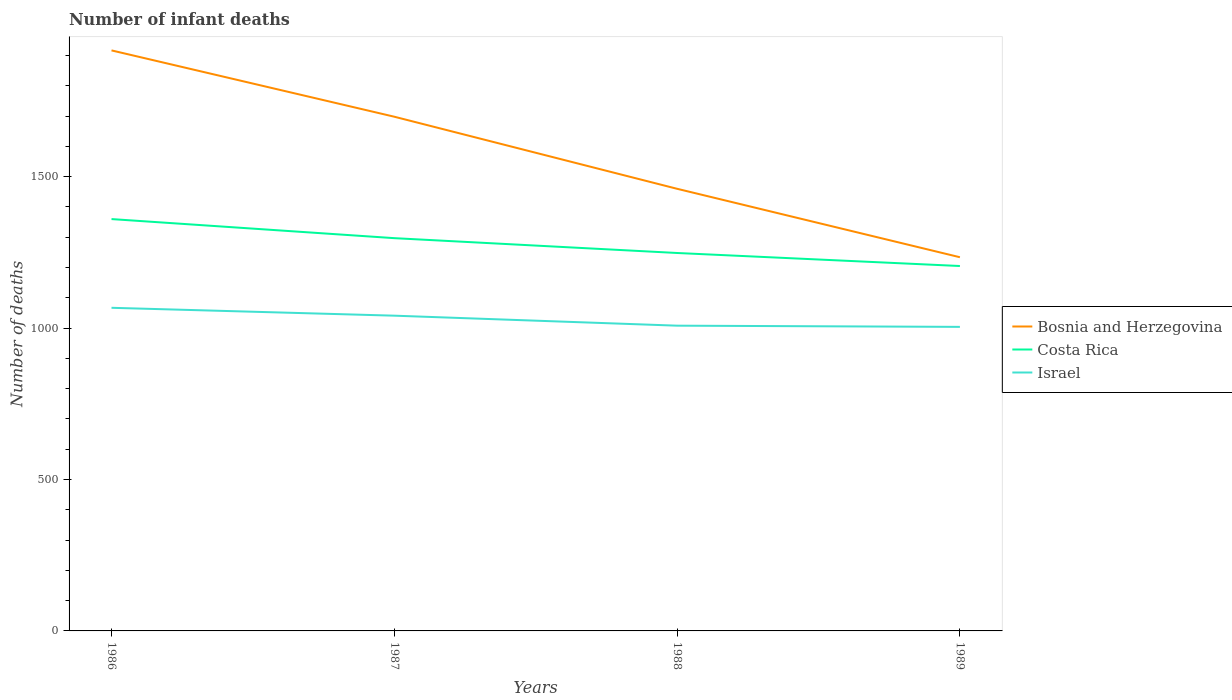Across all years, what is the maximum number of infant deaths in Israel?
Make the answer very short. 1004. In which year was the number of infant deaths in Costa Rica maximum?
Offer a very short reply. 1989. What is the total number of infant deaths in Israel in the graph?
Your answer should be compact. 37. What is the difference between the highest and the second highest number of infant deaths in Costa Rica?
Offer a terse response. 155. Is the number of infant deaths in Costa Rica strictly greater than the number of infant deaths in Bosnia and Herzegovina over the years?
Provide a succinct answer. Yes. What is the difference between two consecutive major ticks on the Y-axis?
Ensure brevity in your answer.  500. Are the values on the major ticks of Y-axis written in scientific E-notation?
Make the answer very short. No. Does the graph contain any zero values?
Offer a terse response. No. Does the graph contain grids?
Provide a succinct answer. No. What is the title of the graph?
Offer a very short reply. Number of infant deaths. Does "Costa Rica" appear as one of the legend labels in the graph?
Ensure brevity in your answer.  Yes. What is the label or title of the X-axis?
Your response must be concise. Years. What is the label or title of the Y-axis?
Provide a succinct answer. Number of deaths. What is the Number of deaths of Bosnia and Herzegovina in 1986?
Your answer should be compact. 1917. What is the Number of deaths in Costa Rica in 1986?
Your response must be concise. 1360. What is the Number of deaths of Israel in 1986?
Provide a succinct answer. 1067. What is the Number of deaths of Bosnia and Herzegovina in 1987?
Provide a short and direct response. 1698. What is the Number of deaths in Costa Rica in 1987?
Offer a terse response. 1297. What is the Number of deaths in Israel in 1987?
Your answer should be compact. 1041. What is the Number of deaths in Bosnia and Herzegovina in 1988?
Provide a succinct answer. 1460. What is the Number of deaths in Costa Rica in 1988?
Provide a short and direct response. 1248. What is the Number of deaths of Israel in 1988?
Make the answer very short. 1008. What is the Number of deaths in Bosnia and Herzegovina in 1989?
Your response must be concise. 1234. What is the Number of deaths of Costa Rica in 1989?
Offer a very short reply. 1205. What is the Number of deaths in Israel in 1989?
Make the answer very short. 1004. Across all years, what is the maximum Number of deaths of Bosnia and Herzegovina?
Make the answer very short. 1917. Across all years, what is the maximum Number of deaths in Costa Rica?
Offer a very short reply. 1360. Across all years, what is the maximum Number of deaths of Israel?
Your response must be concise. 1067. Across all years, what is the minimum Number of deaths of Bosnia and Herzegovina?
Provide a short and direct response. 1234. Across all years, what is the minimum Number of deaths of Costa Rica?
Offer a very short reply. 1205. Across all years, what is the minimum Number of deaths in Israel?
Offer a terse response. 1004. What is the total Number of deaths of Bosnia and Herzegovina in the graph?
Provide a succinct answer. 6309. What is the total Number of deaths in Costa Rica in the graph?
Your answer should be compact. 5110. What is the total Number of deaths of Israel in the graph?
Provide a short and direct response. 4120. What is the difference between the Number of deaths in Bosnia and Herzegovina in 1986 and that in 1987?
Ensure brevity in your answer.  219. What is the difference between the Number of deaths of Israel in 1986 and that in 1987?
Your response must be concise. 26. What is the difference between the Number of deaths of Bosnia and Herzegovina in 1986 and that in 1988?
Ensure brevity in your answer.  457. What is the difference between the Number of deaths of Costa Rica in 1986 and that in 1988?
Make the answer very short. 112. What is the difference between the Number of deaths in Bosnia and Herzegovina in 1986 and that in 1989?
Your answer should be compact. 683. What is the difference between the Number of deaths of Costa Rica in 1986 and that in 1989?
Offer a very short reply. 155. What is the difference between the Number of deaths of Bosnia and Herzegovina in 1987 and that in 1988?
Your answer should be very brief. 238. What is the difference between the Number of deaths of Bosnia and Herzegovina in 1987 and that in 1989?
Your answer should be compact. 464. What is the difference between the Number of deaths in Costa Rica in 1987 and that in 1989?
Offer a terse response. 92. What is the difference between the Number of deaths in Israel in 1987 and that in 1989?
Provide a short and direct response. 37. What is the difference between the Number of deaths of Bosnia and Herzegovina in 1988 and that in 1989?
Provide a short and direct response. 226. What is the difference between the Number of deaths of Costa Rica in 1988 and that in 1989?
Provide a succinct answer. 43. What is the difference between the Number of deaths of Bosnia and Herzegovina in 1986 and the Number of deaths of Costa Rica in 1987?
Ensure brevity in your answer.  620. What is the difference between the Number of deaths in Bosnia and Herzegovina in 1986 and the Number of deaths in Israel in 1987?
Offer a very short reply. 876. What is the difference between the Number of deaths in Costa Rica in 1986 and the Number of deaths in Israel in 1987?
Your answer should be very brief. 319. What is the difference between the Number of deaths of Bosnia and Herzegovina in 1986 and the Number of deaths of Costa Rica in 1988?
Provide a succinct answer. 669. What is the difference between the Number of deaths in Bosnia and Herzegovina in 1986 and the Number of deaths in Israel in 1988?
Provide a short and direct response. 909. What is the difference between the Number of deaths in Costa Rica in 1986 and the Number of deaths in Israel in 1988?
Offer a terse response. 352. What is the difference between the Number of deaths of Bosnia and Herzegovina in 1986 and the Number of deaths of Costa Rica in 1989?
Offer a very short reply. 712. What is the difference between the Number of deaths in Bosnia and Herzegovina in 1986 and the Number of deaths in Israel in 1989?
Offer a terse response. 913. What is the difference between the Number of deaths in Costa Rica in 1986 and the Number of deaths in Israel in 1989?
Your answer should be compact. 356. What is the difference between the Number of deaths of Bosnia and Herzegovina in 1987 and the Number of deaths of Costa Rica in 1988?
Provide a succinct answer. 450. What is the difference between the Number of deaths of Bosnia and Herzegovina in 1987 and the Number of deaths of Israel in 1988?
Keep it short and to the point. 690. What is the difference between the Number of deaths of Costa Rica in 1987 and the Number of deaths of Israel in 1988?
Provide a short and direct response. 289. What is the difference between the Number of deaths in Bosnia and Herzegovina in 1987 and the Number of deaths in Costa Rica in 1989?
Keep it short and to the point. 493. What is the difference between the Number of deaths of Bosnia and Herzegovina in 1987 and the Number of deaths of Israel in 1989?
Give a very brief answer. 694. What is the difference between the Number of deaths of Costa Rica in 1987 and the Number of deaths of Israel in 1989?
Offer a terse response. 293. What is the difference between the Number of deaths of Bosnia and Herzegovina in 1988 and the Number of deaths of Costa Rica in 1989?
Your answer should be compact. 255. What is the difference between the Number of deaths of Bosnia and Herzegovina in 1988 and the Number of deaths of Israel in 1989?
Provide a succinct answer. 456. What is the difference between the Number of deaths of Costa Rica in 1988 and the Number of deaths of Israel in 1989?
Your answer should be very brief. 244. What is the average Number of deaths in Bosnia and Herzegovina per year?
Ensure brevity in your answer.  1577.25. What is the average Number of deaths of Costa Rica per year?
Provide a short and direct response. 1277.5. What is the average Number of deaths of Israel per year?
Provide a succinct answer. 1030. In the year 1986, what is the difference between the Number of deaths of Bosnia and Herzegovina and Number of deaths of Costa Rica?
Make the answer very short. 557. In the year 1986, what is the difference between the Number of deaths of Bosnia and Herzegovina and Number of deaths of Israel?
Ensure brevity in your answer.  850. In the year 1986, what is the difference between the Number of deaths of Costa Rica and Number of deaths of Israel?
Keep it short and to the point. 293. In the year 1987, what is the difference between the Number of deaths of Bosnia and Herzegovina and Number of deaths of Costa Rica?
Ensure brevity in your answer.  401. In the year 1987, what is the difference between the Number of deaths in Bosnia and Herzegovina and Number of deaths in Israel?
Offer a very short reply. 657. In the year 1987, what is the difference between the Number of deaths of Costa Rica and Number of deaths of Israel?
Give a very brief answer. 256. In the year 1988, what is the difference between the Number of deaths in Bosnia and Herzegovina and Number of deaths in Costa Rica?
Your answer should be very brief. 212. In the year 1988, what is the difference between the Number of deaths of Bosnia and Herzegovina and Number of deaths of Israel?
Offer a very short reply. 452. In the year 1988, what is the difference between the Number of deaths in Costa Rica and Number of deaths in Israel?
Keep it short and to the point. 240. In the year 1989, what is the difference between the Number of deaths in Bosnia and Herzegovina and Number of deaths in Israel?
Ensure brevity in your answer.  230. In the year 1989, what is the difference between the Number of deaths in Costa Rica and Number of deaths in Israel?
Provide a succinct answer. 201. What is the ratio of the Number of deaths in Bosnia and Herzegovina in 1986 to that in 1987?
Give a very brief answer. 1.13. What is the ratio of the Number of deaths of Costa Rica in 1986 to that in 1987?
Your answer should be very brief. 1.05. What is the ratio of the Number of deaths of Bosnia and Herzegovina in 1986 to that in 1988?
Offer a terse response. 1.31. What is the ratio of the Number of deaths of Costa Rica in 1986 to that in 1988?
Make the answer very short. 1.09. What is the ratio of the Number of deaths of Israel in 1986 to that in 1988?
Your answer should be very brief. 1.06. What is the ratio of the Number of deaths in Bosnia and Herzegovina in 1986 to that in 1989?
Offer a very short reply. 1.55. What is the ratio of the Number of deaths in Costa Rica in 1986 to that in 1989?
Provide a succinct answer. 1.13. What is the ratio of the Number of deaths in Israel in 1986 to that in 1989?
Provide a succinct answer. 1.06. What is the ratio of the Number of deaths in Bosnia and Herzegovina in 1987 to that in 1988?
Give a very brief answer. 1.16. What is the ratio of the Number of deaths of Costa Rica in 1987 to that in 1988?
Offer a terse response. 1.04. What is the ratio of the Number of deaths in Israel in 1987 to that in 1988?
Your answer should be very brief. 1.03. What is the ratio of the Number of deaths in Bosnia and Herzegovina in 1987 to that in 1989?
Offer a terse response. 1.38. What is the ratio of the Number of deaths of Costa Rica in 1987 to that in 1989?
Give a very brief answer. 1.08. What is the ratio of the Number of deaths of Israel in 1987 to that in 1989?
Provide a short and direct response. 1.04. What is the ratio of the Number of deaths in Bosnia and Herzegovina in 1988 to that in 1989?
Provide a short and direct response. 1.18. What is the ratio of the Number of deaths of Costa Rica in 1988 to that in 1989?
Keep it short and to the point. 1.04. What is the ratio of the Number of deaths of Israel in 1988 to that in 1989?
Provide a succinct answer. 1. What is the difference between the highest and the second highest Number of deaths of Bosnia and Herzegovina?
Keep it short and to the point. 219. What is the difference between the highest and the second highest Number of deaths of Israel?
Keep it short and to the point. 26. What is the difference between the highest and the lowest Number of deaths in Bosnia and Herzegovina?
Your answer should be very brief. 683. What is the difference between the highest and the lowest Number of deaths of Costa Rica?
Your response must be concise. 155. What is the difference between the highest and the lowest Number of deaths in Israel?
Your response must be concise. 63. 